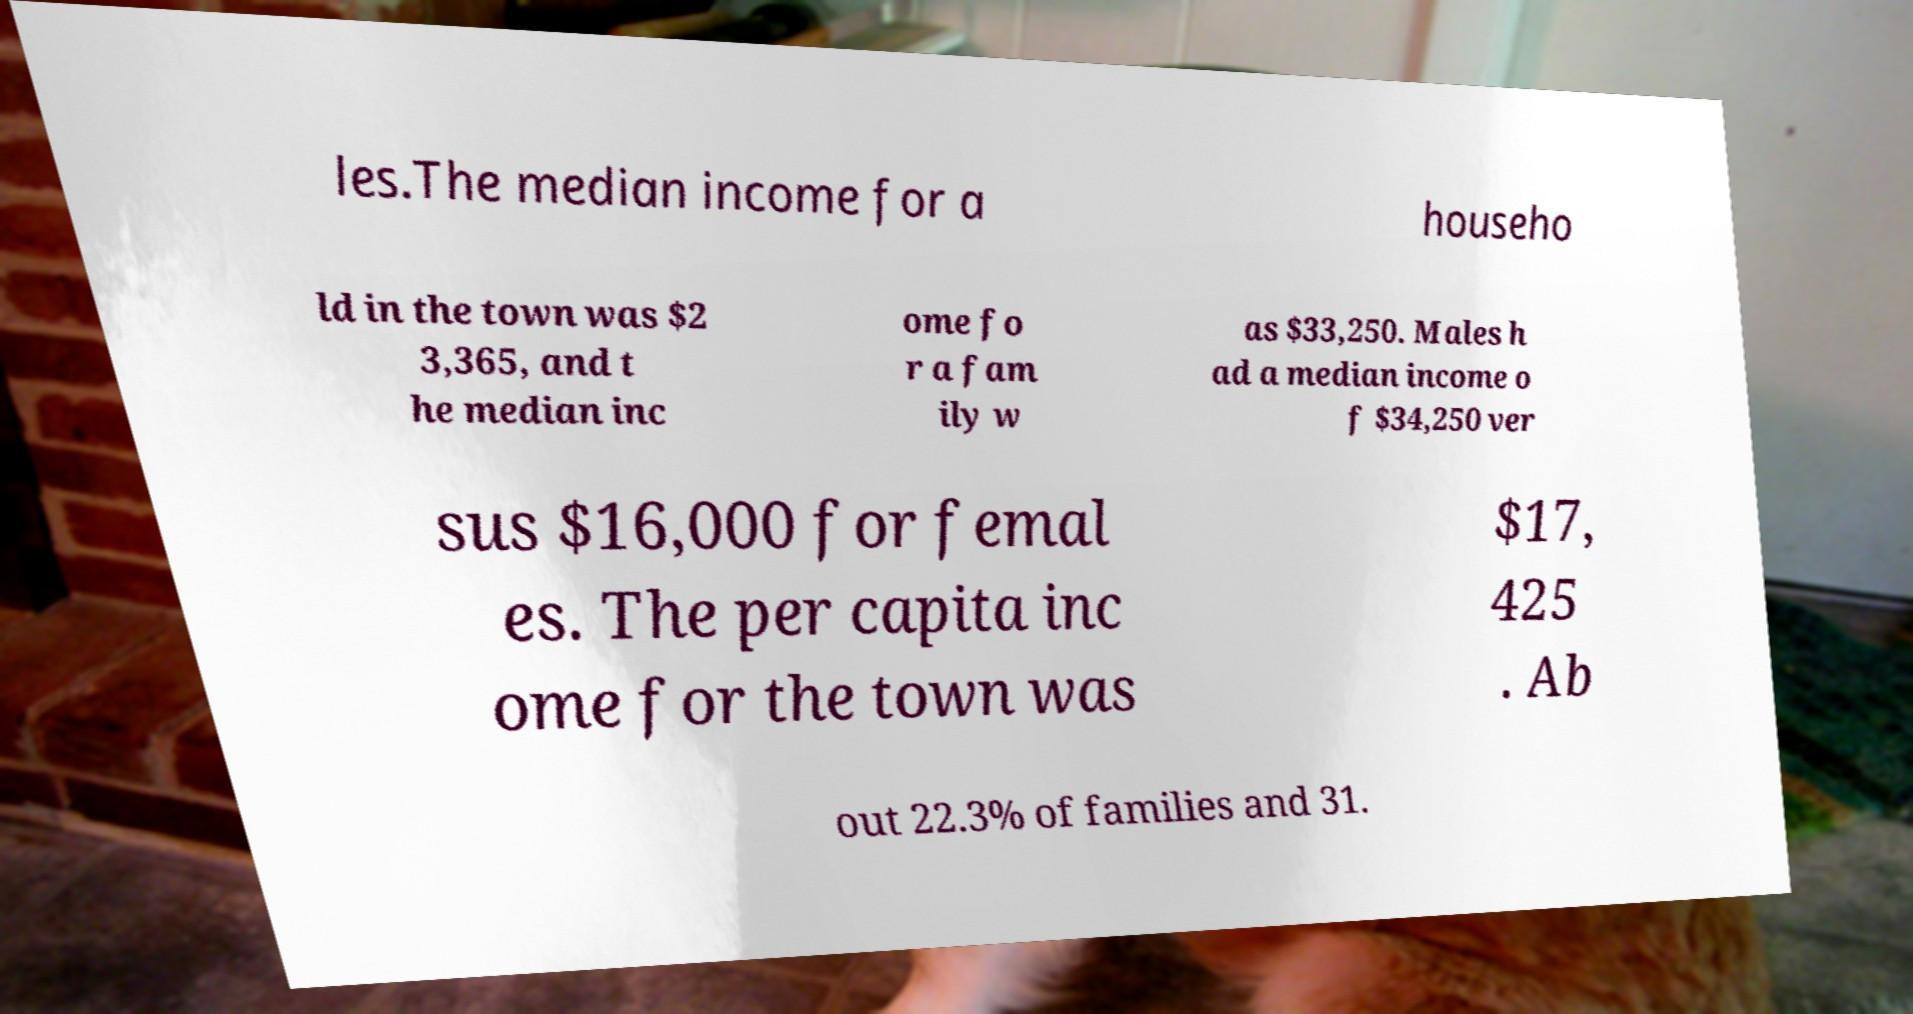Can you read and provide the text displayed in the image?This photo seems to have some interesting text. Can you extract and type it out for me? les.The median income for a househo ld in the town was $2 3,365, and t he median inc ome fo r a fam ily w as $33,250. Males h ad a median income o f $34,250 ver sus $16,000 for femal es. The per capita inc ome for the town was $17, 425 . Ab out 22.3% of families and 31. 